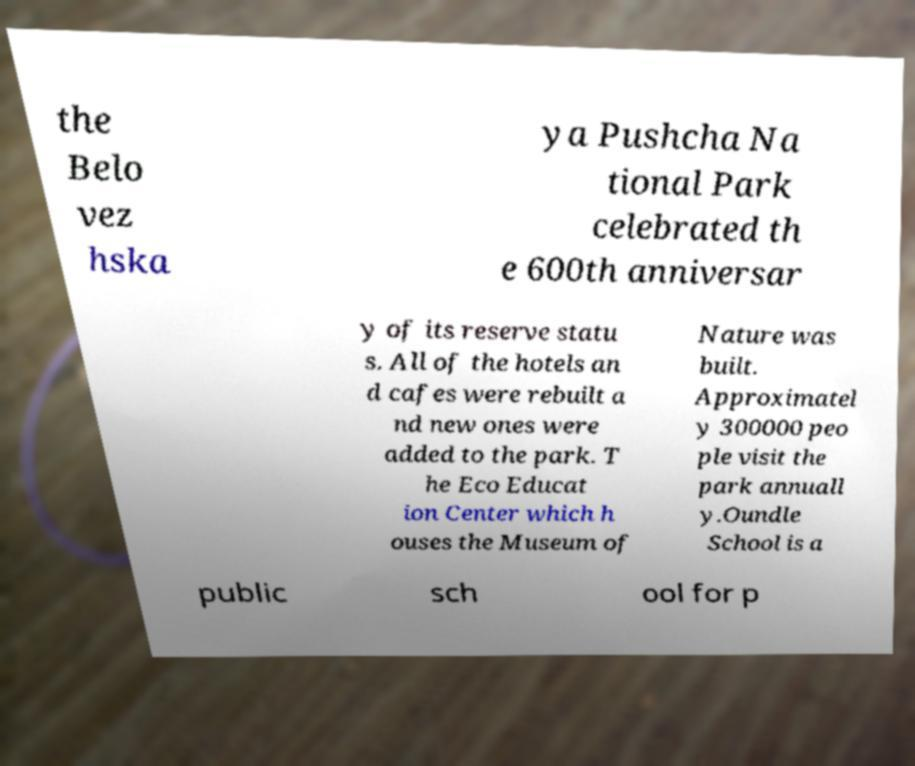Could you assist in decoding the text presented in this image and type it out clearly? the Belo vez hska ya Pushcha Na tional Park celebrated th e 600th anniversar y of its reserve statu s. All of the hotels an d cafes were rebuilt a nd new ones were added to the park. T he Eco Educat ion Center which h ouses the Museum of Nature was built. Approximatel y 300000 peo ple visit the park annuall y.Oundle School is a public sch ool for p 